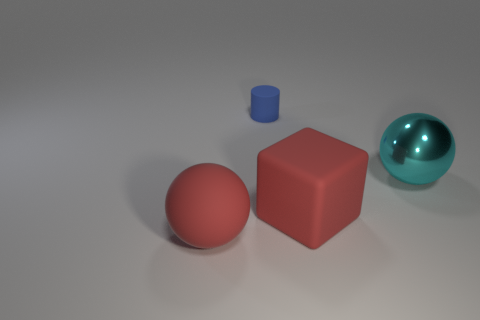Subtract all purple blocks. Subtract all purple cylinders. How many blocks are left? 1 Add 2 blue things. How many objects exist? 6 Subtract all cubes. How many objects are left? 3 Add 2 tiny blue cylinders. How many tiny blue cylinders exist? 3 Subtract 0 green cylinders. How many objects are left? 4 Subtract all tiny green rubber blocks. Subtract all metal objects. How many objects are left? 3 Add 3 red blocks. How many red blocks are left? 4 